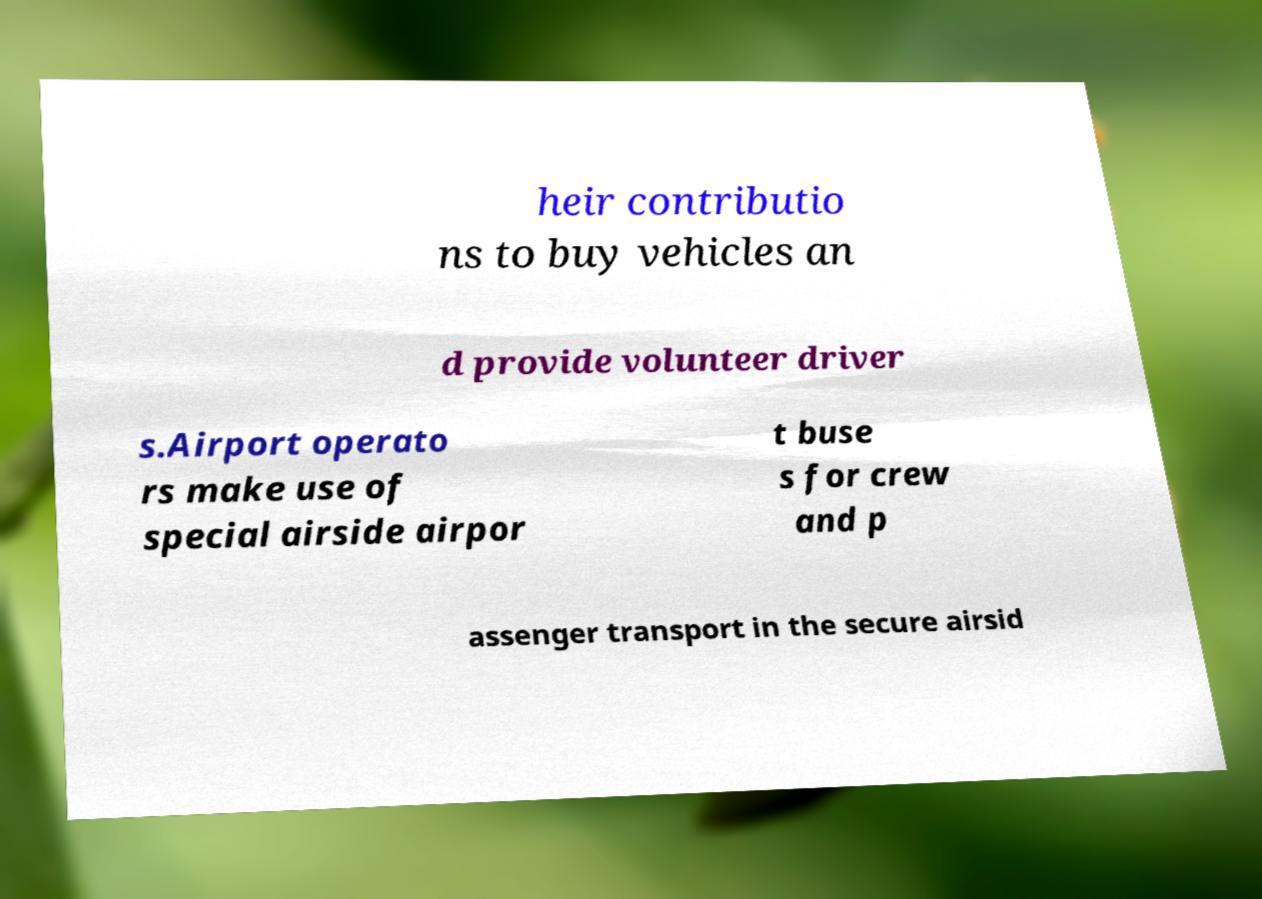There's text embedded in this image that I need extracted. Can you transcribe it verbatim? heir contributio ns to buy vehicles an d provide volunteer driver s.Airport operato rs make use of special airside airpor t buse s for crew and p assenger transport in the secure airsid 